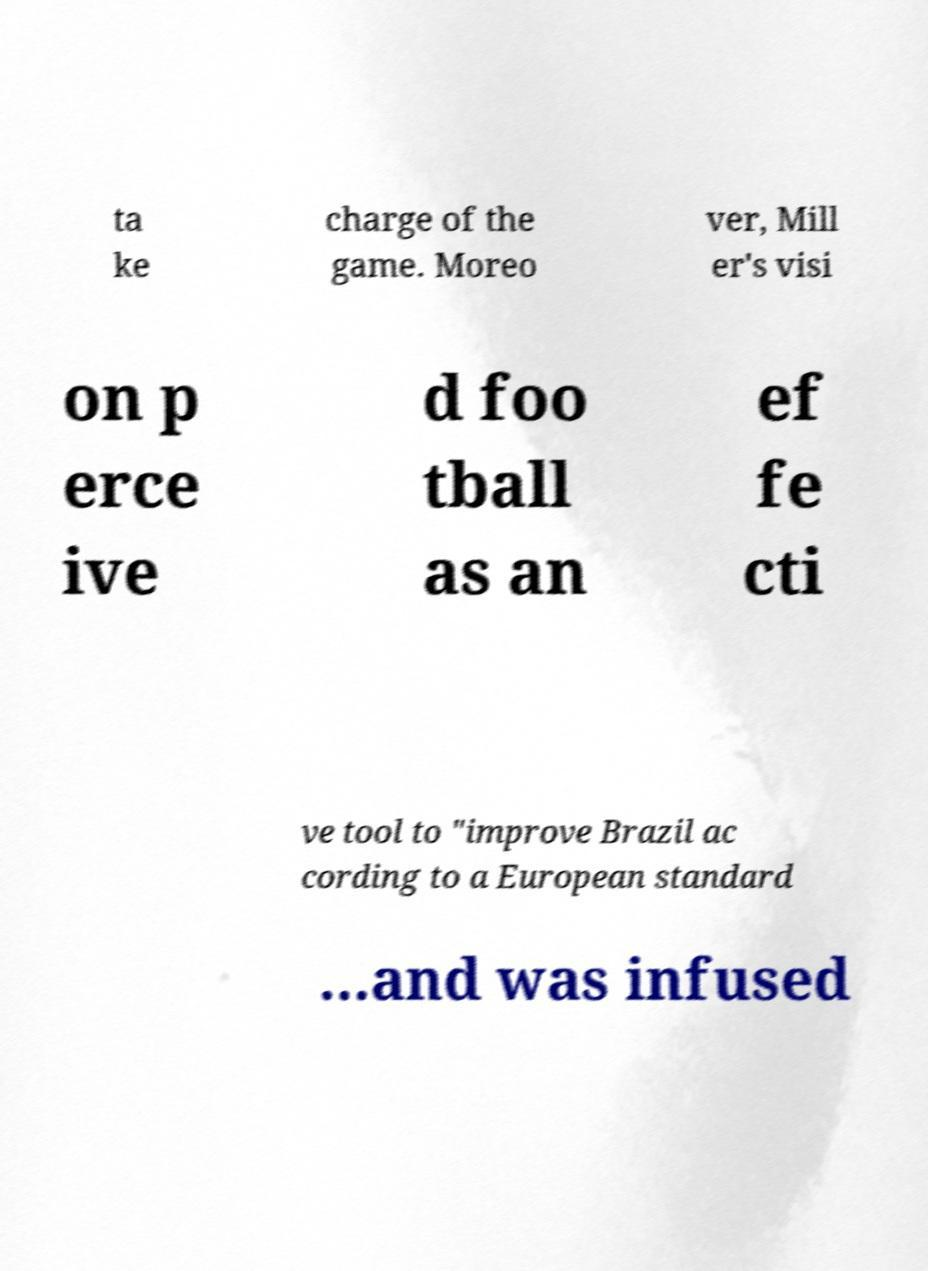Can you read and provide the text displayed in the image?This photo seems to have some interesting text. Can you extract and type it out for me? ta ke charge of the game. Moreo ver, Mill er's visi on p erce ive d foo tball as an ef fe cti ve tool to "improve Brazil ac cording to a European standard …and was infused 